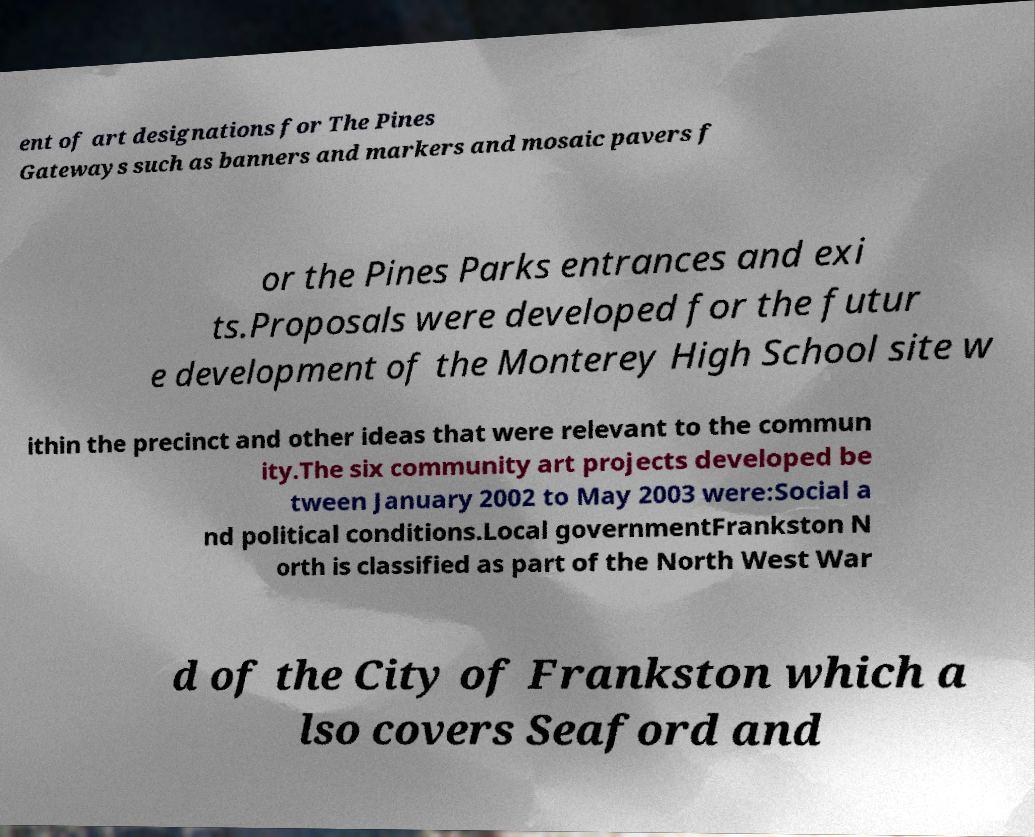I need the written content from this picture converted into text. Can you do that? ent of art designations for The Pines Gateways such as banners and markers and mosaic pavers f or the Pines Parks entrances and exi ts.Proposals were developed for the futur e development of the Monterey High School site w ithin the precinct and other ideas that were relevant to the commun ity.The six community art projects developed be tween January 2002 to May 2003 were:Social a nd political conditions.Local governmentFrankston N orth is classified as part of the North West War d of the City of Frankston which a lso covers Seaford and 